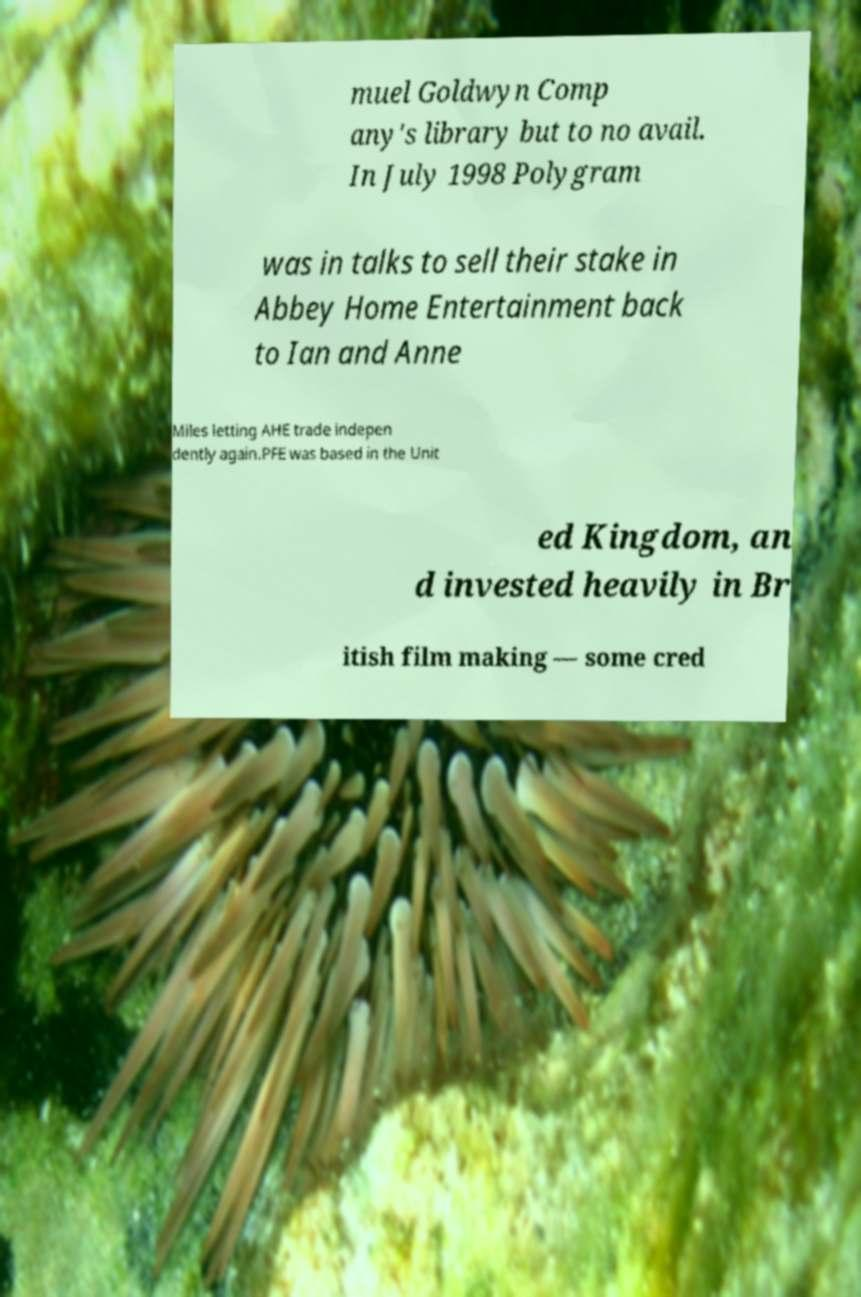Please read and relay the text visible in this image. What does it say? muel Goldwyn Comp any's library but to no avail. In July 1998 Polygram was in talks to sell their stake in Abbey Home Entertainment back to Ian and Anne Miles letting AHE trade indepen dently again.PFE was based in the Unit ed Kingdom, an d invested heavily in Br itish film making — some cred 